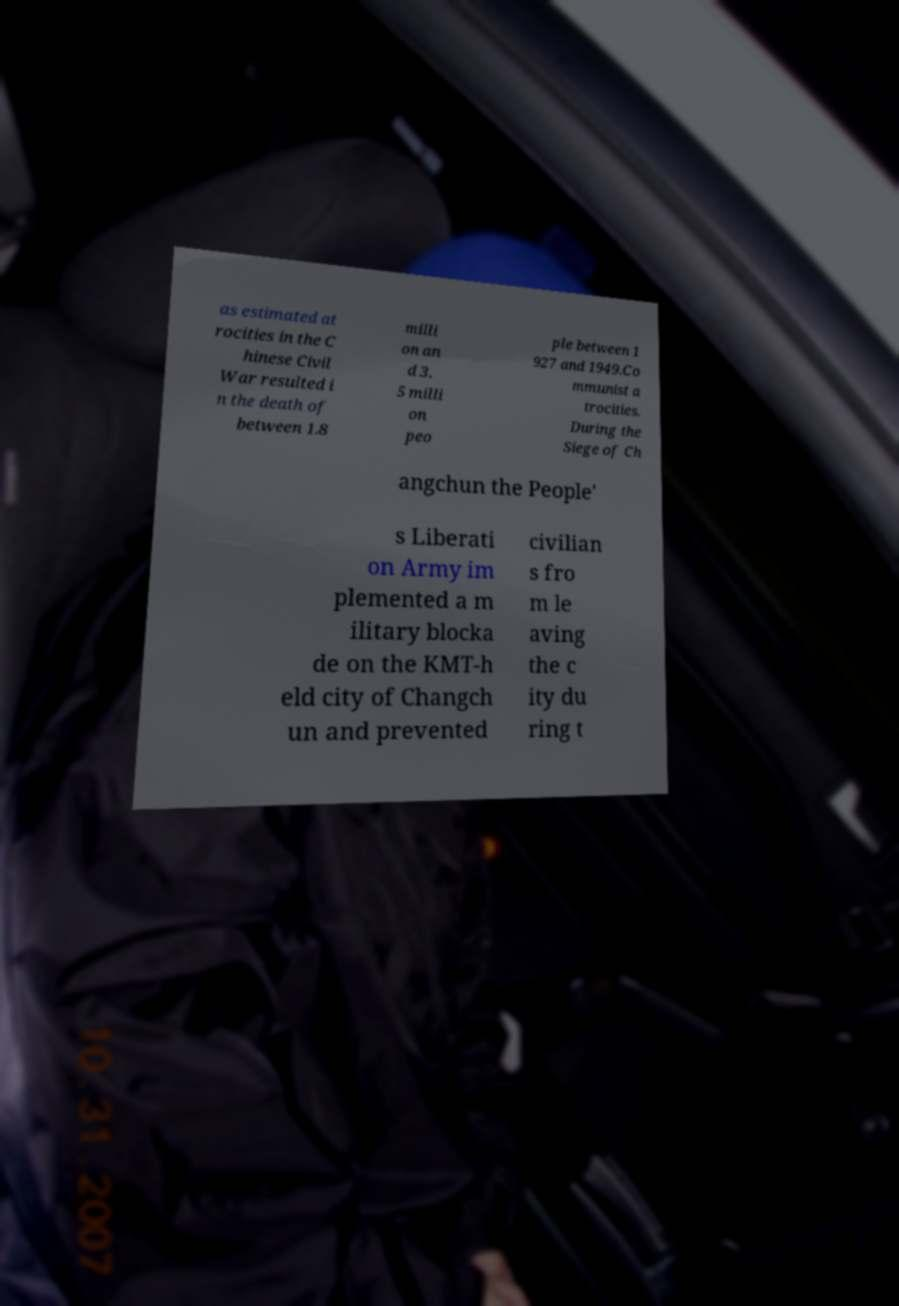I need the written content from this picture converted into text. Can you do that? as estimated at rocities in the C hinese Civil War resulted i n the death of between 1.8 milli on an d 3. 5 milli on peo ple between 1 927 and 1949.Co mmunist a trocities. During the Siege of Ch angchun the People' s Liberati on Army im plemented a m ilitary blocka de on the KMT-h eld city of Changch un and prevented civilian s fro m le aving the c ity du ring t 